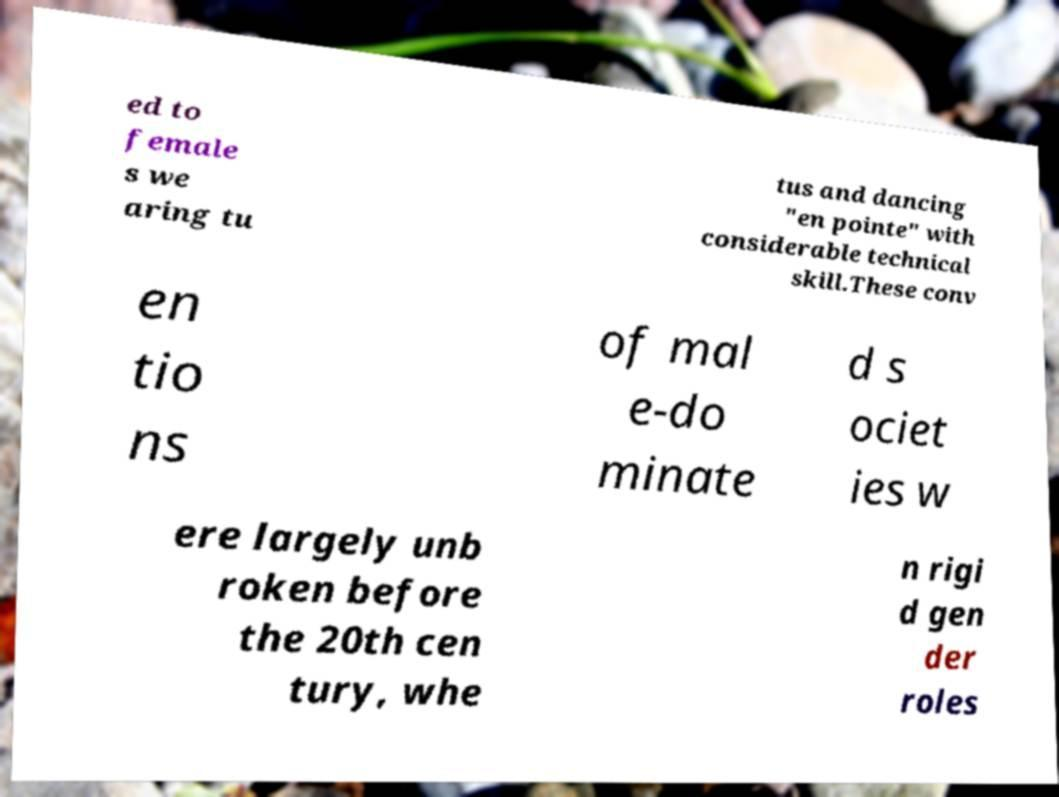What messages or text are displayed in this image? I need them in a readable, typed format. ed to female s we aring tu tus and dancing "en pointe" with considerable technical skill.These conv en tio ns of mal e-do minate d s ociet ies w ere largely unb roken before the 20th cen tury, whe n rigi d gen der roles 